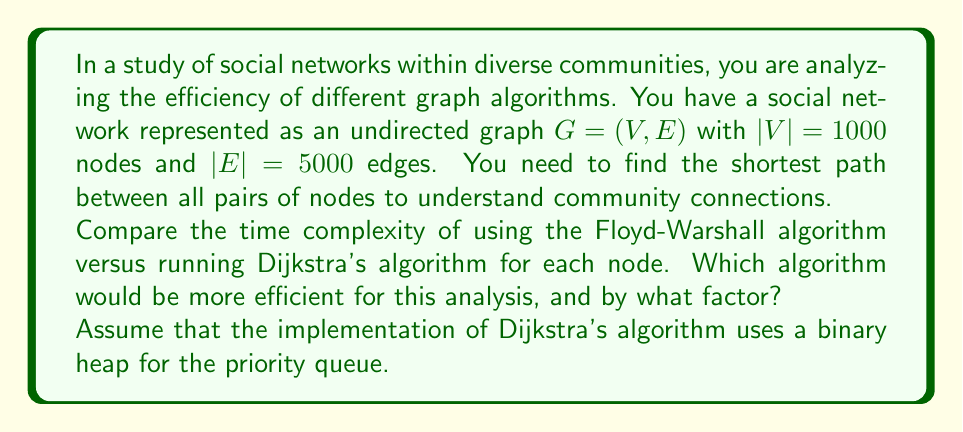What is the answer to this math problem? To solve this problem, we need to calculate and compare the time complexities of both algorithms:

1. Floyd-Warshall Algorithm:
   - Time complexity: $O(|V|^3)$
   - For our graph: $O(1000^3) = O(10^9)$ operations

2. Dijkstra's Algorithm (with binary heap) for all nodes:
   - Time complexity for one execution: $O((|E| + |V|) \log |V|)$
   - We need to run it $|V|$ times, one for each node
   - Total time complexity: $O(|V|(|E| + |V|) \log |V|)$
   - For our graph: $O(1000(5000 + 1000) \log 1000)$
   
   Let's simplify:
   $1000(5000 + 1000) \log 1000$
   $= 1000 \cdot 6000 \cdot \log 1000$
   $\approx 6 \cdot 10^6 \cdot 10$
   $= 6 \cdot 10^7$ operations

Comparing the two:
- Floyd-Warshall: $O(10^9)$ operations
- Dijkstra for all nodes: $O(6 \cdot 10^7)$ operations

The ratio of Floyd-Warshall to Dijkstra's:
$$\frac{10^9}{6 \cdot 10^7} \approx 16.67$$

Therefore, Dijkstra's algorithm run for each node is more efficient for this analysis, by a factor of approximately 16.67.

This result highlights the importance of choosing appropriate algorithms when analyzing diverse community networks, as it can significantly impact the efficiency of the analysis and allow for more inclusive and comprehensive studies of social connections.
Answer: Dijkstra's algorithm run for each node is more efficient, by a factor of approximately 16.67. 